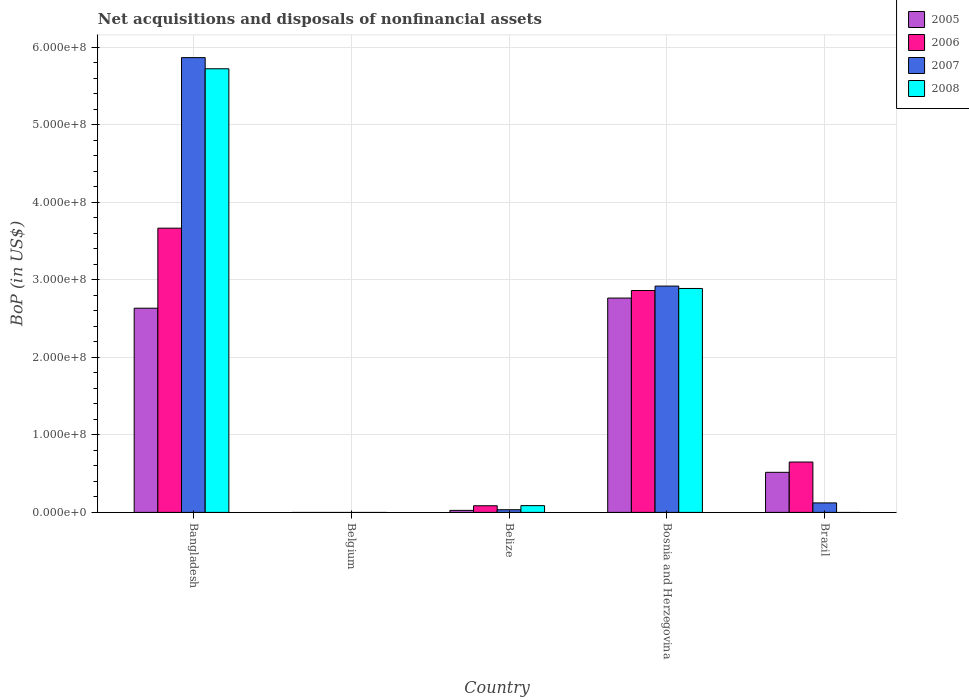How many different coloured bars are there?
Offer a very short reply. 4. Are the number of bars per tick equal to the number of legend labels?
Offer a terse response. No. Are the number of bars on each tick of the X-axis equal?
Provide a short and direct response. No. How many bars are there on the 3rd tick from the left?
Ensure brevity in your answer.  4. What is the label of the 5th group of bars from the left?
Your answer should be very brief. Brazil. In how many cases, is the number of bars for a given country not equal to the number of legend labels?
Offer a very short reply. 2. What is the Balance of Payments in 2008 in Bosnia and Herzegovina?
Offer a very short reply. 2.89e+08. Across all countries, what is the maximum Balance of Payments in 2006?
Your response must be concise. 3.67e+08. In which country was the Balance of Payments in 2005 maximum?
Provide a succinct answer. Bosnia and Herzegovina. What is the total Balance of Payments in 2007 in the graph?
Your answer should be very brief. 8.94e+08. What is the difference between the Balance of Payments in 2007 in Bangladesh and that in Brazil?
Your response must be concise. 5.74e+08. What is the difference between the Balance of Payments in 2008 in Belize and the Balance of Payments in 2005 in Bangladesh?
Your response must be concise. -2.55e+08. What is the average Balance of Payments in 2006 per country?
Make the answer very short. 1.45e+08. What is the difference between the Balance of Payments of/in 2007 and Balance of Payments of/in 2006 in Bosnia and Herzegovina?
Give a very brief answer. 5.67e+06. What is the ratio of the Balance of Payments in 2006 in Bosnia and Herzegovina to that in Brazil?
Give a very brief answer. 4.41. What is the difference between the highest and the second highest Balance of Payments in 2006?
Your response must be concise. -3.02e+08. What is the difference between the highest and the lowest Balance of Payments in 2007?
Offer a very short reply. 5.87e+08. Is the sum of the Balance of Payments in 2005 in Bangladesh and Belize greater than the maximum Balance of Payments in 2007 across all countries?
Make the answer very short. No. Is it the case that in every country, the sum of the Balance of Payments in 2005 and Balance of Payments in 2006 is greater than the sum of Balance of Payments in 2007 and Balance of Payments in 2008?
Provide a succinct answer. No. Is it the case that in every country, the sum of the Balance of Payments in 2005 and Balance of Payments in 2008 is greater than the Balance of Payments in 2006?
Your answer should be very brief. No. Are the values on the major ticks of Y-axis written in scientific E-notation?
Make the answer very short. Yes. Where does the legend appear in the graph?
Keep it short and to the point. Top right. How many legend labels are there?
Provide a short and direct response. 4. What is the title of the graph?
Your answer should be compact. Net acquisitions and disposals of nonfinancial assets. What is the label or title of the Y-axis?
Your answer should be compact. BoP (in US$). What is the BoP (in US$) in 2005 in Bangladesh?
Your response must be concise. 2.63e+08. What is the BoP (in US$) of 2006 in Bangladesh?
Ensure brevity in your answer.  3.67e+08. What is the BoP (in US$) in 2007 in Bangladesh?
Make the answer very short. 5.87e+08. What is the BoP (in US$) in 2008 in Bangladesh?
Your answer should be compact. 5.72e+08. What is the BoP (in US$) of 2005 in Belgium?
Provide a short and direct response. 0. What is the BoP (in US$) of 2008 in Belgium?
Offer a very short reply. 0. What is the BoP (in US$) in 2005 in Belize?
Provide a short and direct response. 2.59e+06. What is the BoP (in US$) in 2006 in Belize?
Give a very brief answer. 8.57e+06. What is the BoP (in US$) in 2007 in Belize?
Your answer should be very brief. 3.45e+06. What is the BoP (in US$) in 2008 in Belize?
Ensure brevity in your answer.  8.73e+06. What is the BoP (in US$) of 2005 in Bosnia and Herzegovina?
Provide a succinct answer. 2.76e+08. What is the BoP (in US$) in 2006 in Bosnia and Herzegovina?
Ensure brevity in your answer.  2.86e+08. What is the BoP (in US$) in 2007 in Bosnia and Herzegovina?
Provide a succinct answer. 2.92e+08. What is the BoP (in US$) of 2008 in Bosnia and Herzegovina?
Ensure brevity in your answer.  2.89e+08. What is the BoP (in US$) of 2005 in Brazil?
Offer a very short reply. 5.17e+07. What is the BoP (in US$) of 2006 in Brazil?
Your response must be concise. 6.50e+07. What is the BoP (in US$) of 2007 in Brazil?
Your answer should be very brief. 1.22e+07. Across all countries, what is the maximum BoP (in US$) in 2005?
Make the answer very short. 2.76e+08. Across all countries, what is the maximum BoP (in US$) of 2006?
Provide a succinct answer. 3.67e+08. Across all countries, what is the maximum BoP (in US$) in 2007?
Your answer should be very brief. 5.87e+08. Across all countries, what is the maximum BoP (in US$) in 2008?
Give a very brief answer. 5.72e+08. Across all countries, what is the minimum BoP (in US$) in 2005?
Your answer should be very brief. 0. Across all countries, what is the minimum BoP (in US$) of 2006?
Provide a succinct answer. 0. Across all countries, what is the minimum BoP (in US$) in 2007?
Make the answer very short. 0. What is the total BoP (in US$) in 2005 in the graph?
Offer a very short reply. 5.94e+08. What is the total BoP (in US$) of 2006 in the graph?
Keep it short and to the point. 7.26e+08. What is the total BoP (in US$) in 2007 in the graph?
Provide a short and direct response. 8.94e+08. What is the total BoP (in US$) in 2008 in the graph?
Your answer should be compact. 8.70e+08. What is the difference between the BoP (in US$) of 2005 in Bangladesh and that in Belize?
Keep it short and to the point. 2.61e+08. What is the difference between the BoP (in US$) in 2006 in Bangladesh and that in Belize?
Make the answer very short. 3.58e+08. What is the difference between the BoP (in US$) in 2007 in Bangladesh and that in Belize?
Provide a short and direct response. 5.83e+08. What is the difference between the BoP (in US$) of 2008 in Bangladesh and that in Belize?
Offer a very short reply. 5.63e+08. What is the difference between the BoP (in US$) of 2005 in Bangladesh and that in Bosnia and Herzegovina?
Give a very brief answer. -1.31e+07. What is the difference between the BoP (in US$) of 2006 in Bangladesh and that in Bosnia and Herzegovina?
Your answer should be compact. 8.04e+07. What is the difference between the BoP (in US$) in 2007 in Bangladesh and that in Bosnia and Herzegovina?
Your answer should be compact. 2.95e+08. What is the difference between the BoP (in US$) of 2008 in Bangladesh and that in Bosnia and Herzegovina?
Provide a short and direct response. 2.83e+08. What is the difference between the BoP (in US$) in 2005 in Bangladesh and that in Brazil?
Offer a very short reply. 2.12e+08. What is the difference between the BoP (in US$) in 2006 in Bangladesh and that in Brazil?
Ensure brevity in your answer.  3.02e+08. What is the difference between the BoP (in US$) in 2007 in Bangladesh and that in Brazil?
Make the answer very short. 5.74e+08. What is the difference between the BoP (in US$) of 2005 in Belize and that in Bosnia and Herzegovina?
Make the answer very short. -2.74e+08. What is the difference between the BoP (in US$) in 2006 in Belize and that in Bosnia and Herzegovina?
Keep it short and to the point. -2.78e+08. What is the difference between the BoP (in US$) in 2007 in Belize and that in Bosnia and Herzegovina?
Ensure brevity in your answer.  -2.88e+08. What is the difference between the BoP (in US$) of 2008 in Belize and that in Bosnia and Herzegovina?
Your answer should be compact. -2.80e+08. What is the difference between the BoP (in US$) of 2005 in Belize and that in Brazil?
Keep it short and to the point. -4.91e+07. What is the difference between the BoP (in US$) in 2006 in Belize and that in Brazil?
Your answer should be compact. -5.64e+07. What is the difference between the BoP (in US$) of 2007 in Belize and that in Brazil?
Provide a succinct answer. -8.78e+06. What is the difference between the BoP (in US$) of 2005 in Bosnia and Herzegovina and that in Brazil?
Provide a succinct answer. 2.25e+08. What is the difference between the BoP (in US$) of 2006 in Bosnia and Herzegovina and that in Brazil?
Your answer should be very brief. 2.21e+08. What is the difference between the BoP (in US$) of 2007 in Bosnia and Herzegovina and that in Brazil?
Give a very brief answer. 2.80e+08. What is the difference between the BoP (in US$) in 2005 in Bangladesh and the BoP (in US$) in 2006 in Belize?
Make the answer very short. 2.55e+08. What is the difference between the BoP (in US$) in 2005 in Bangladesh and the BoP (in US$) in 2007 in Belize?
Make the answer very short. 2.60e+08. What is the difference between the BoP (in US$) in 2005 in Bangladesh and the BoP (in US$) in 2008 in Belize?
Ensure brevity in your answer.  2.55e+08. What is the difference between the BoP (in US$) in 2006 in Bangladesh and the BoP (in US$) in 2007 in Belize?
Keep it short and to the point. 3.63e+08. What is the difference between the BoP (in US$) in 2006 in Bangladesh and the BoP (in US$) in 2008 in Belize?
Give a very brief answer. 3.58e+08. What is the difference between the BoP (in US$) of 2007 in Bangladesh and the BoP (in US$) of 2008 in Belize?
Provide a short and direct response. 5.78e+08. What is the difference between the BoP (in US$) of 2005 in Bangladesh and the BoP (in US$) of 2006 in Bosnia and Herzegovina?
Give a very brief answer. -2.29e+07. What is the difference between the BoP (in US$) in 2005 in Bangladesh and the BoP (in US$) in 2007 in Bosnia and Herzegovina?
Your answer should be very brief. -2.85e+07. What is the difference between the BoP (in US$) in 2005 in Bangladesh and the BoP (in US$) in 2008 in Bosnia and Herzegovina?
Your response must be concise. -2.55e+07. What is the difference between the BoP (in US$) of 2006 in Bangladesh and the BoP (in US$) of 2007 in Bosnia and Herzegovina?
Your answer should be compact. 7.47e+07. What is the difference between the BoP (in US$) of 2006 in Bangladesh and the BoP (in US$) of 2008 in Bosnia and Herzegovina?
Give a very brief answer. 7.78e+07. What is the difference between the BoP (in US$) in 2007 in Bangladesh and the BoP (in US$) in 2008 in Bosnia and Herzegovina?
Offer a terse response. 2.98e+08. What is the difference between the BoP (in US$) in 2005 in Bangladesh and the BoP (in US$) in 2006 in Brazil?
Provide a short and direct response. 1.98e+08. What is the difference between the BoP (in US$) of 2005 in Bangladesh and the BoP (in US$) of 2007 in Brazil?
Make the answer very short. 2.51e+08. What is the difference between the BoP (in US$) of 2006 in Bangladesh and the BoP (in US$) of 2007 in Brazil?
Give a very brief answer. 3.54e+08. What is the difference between the BoP (in US$) in 2005 in Belize and the BoP (in US$) in 2006 in Bosnia and Herzegovina?
Keep it short and to the point. -2.84e+08. What is the difference between the BoP (in US$) of 2005 in Belize and the BoP (in US$) of 2007 in Bosnia and Herzegovina?
Ensure brevity in your answer.  -2.89e+08. What is the difference between the BoP (in US$) in 2005 in Belize and the BoP (in US$) in 2008 in Bosnia and Herzegovina?
Keep it short and to the point. -2.86e+08. What is the difference between the BoP (in US$) in 2006 in Belize and the BoP (in US$) in 2007 in Bosnia and Herzegovina?
Provide a succinct answer. -2.83e+08. What is the difference between the BoP (in US$) in 2006 in Belize and the BoP (in US$) in 2008 in Bosnia and Herzegovina?
Offer a terse response. -2.80e+08. What is the difference between the BoP (in US$) of 2007 in Belize and the BoP (in US$) of 2008 in Bosnia and Herzegovina?
Your answer should be compact. -2.85e+08. What is the difference between the BoP (in US$) in 2005 in Belize and the BoP (in US$) in 2006 in Brazil?
Provide a short and direct response. -6.24e+07. What is the difference between the BoP (in US$) of 2005 in Belize and the BoP (in US$) of 2007 in Brazil?
Offer a terse response. -9.64e+06. What is the difference between the BoP (in US$) of 2006 in Belize and the BoP (in US$) of 2007 in Brazil?
Your answer should be very brief. -3.66e+06. What is the difference between the BoP (in US$) of 2005 in Bosnia and Herzegovina and the BoP (in US$) of 2006 in Brazil?
Make the answer very short. 2.11e+08. What is the difference between the BoP (in US$) in 2005 in Bosnia and Herzegovina and the BoP (in US$) in 2007 in Brazil?
Offer a very short reply. 2.64e+08. What is the difference between the BoP (in US$) of 2006 in Bosnia and Herzegovina and the BoP (in US$) of 2007 in Brazil?
Your answer should be compact. 2.74e+08. What is the average BoP (in US$) in 2005 per country?
Provide a succinct answer. 1.19e+08. What is the average BoP (in US$) in 2006 per country?
Ensure brevity in your answer.  1.45e+08. What is the average BoP (in US$) in 2007 per country?
Your answer should be very brief. 1.79e+08. What is the average BoP (in US$) in 2008 per country?
Provide a short and direct response. 1.74e+08. What is the difference between the BoP (in US$) in 2005 and BoP (in US$) in 2006 in Bangladesh?
Give a very brief answer. -1.03e+08. What is the difference between the BoP (in US$) of 2005 and BoP (in US$) of 2007 in Bangladesh?
Make the answer very short. -3.23e+08. What is the difference between the BoP (in US$) of 2005 and BoP (in US$) of 2008 in Bangladesh?
Make the answer very short. -3.09e+08. What is the difference between the BoP (in US$) in 2006 and BoP (in US$) in 2007 in Bangladesh?
Keep it short and to the point. -2.20e+08. What is the difference between the BoP (in US$) of 2006 and BoP (in US$) of 2008 in Bangladesh?
Your answer should be very brief. -2.06e+08. What is the difference between the BoP (in US$) of 2007 and BoP (in US$) of 2008 in Bangladesh?
Give a very brief answer. 1.44e+07. What is the difference between the BoP (in US$) in 2005 and BoP (in US$) in 2006 in Belize?
Provide a succinct answer. -5.98e+06. What is the difference between the BoP (in US$) of 2005 and BoP (in US$) of 2007 in Belize?
Your answer should be very brief. -8.56e+05. What is the difference between the BoP (in US$) in 2005 and BoP (in US$) in 2008 in Belize?
Ensure brevity in your answer.  -6.14e+06. What is the difference between the BoP (in US$) in 2006 and BoP (in US$) in 2007 in Belize?
Offer a very short reply. 5.12e+06. What is the difference between the BoP (in US$) in 2006 and BoP (in US$) in 2008 in Belize?
Provide a short and direct response. -1.61e+05. What is the difference between the BoP (in US$) in 2007 and BoP (in US$) in 2008 in Belize?
Offer a very short reply. -5.28e+06. What is the difference between the BoP (in US$) of 2005 and BoP (in US$) of 2006 in Bosnia and Herzegovina?
Offer a terse response. -9.77e+06. What is the difference between the BoP (in US$) of 2005 and BoP (in US$) of 2007 in Bosnia and Herzegovina?
Make the answer very short. -1.54e+07. What is the difference between the BoP (in US$) in 2005 and BoP (in US$) in 2008 in Bosnia and Herzegovina?
Your response must be concise. -1.24e+07. What is the difference between the BoP (in US$) of 2006 and BoP (in US$) of 2007 in Bosnia and Herzegovina?
Make the answer very short. -5.67e+06. What is the difference between the BoP (in US$) in 2006 and BoP (in US$) in 2008 in Bosnia and Herzegovina?
Ensure brevity in your answer.  -2.60e+06. What is the difference between the BoP (in US$) in 2007 and BoP (in US$) in 2008 in Bosnia and Herzegovina?
Your response must be concise. 3.07e+06. What is the difference between the BoP (in US$) in 2005 and BoP (in US$) in 2006 in Brazil?
Your answer should be compact. -1.33e+07. What is the difference between the BoP (in US$) of 2005 and BoP (in US$) of 2007 in Brazil?
Your response must be concise. 3.95e+07. What is the difference between the BoP (in US$) in 2006 and BoP (in US$) in 2007 in Brazil?
Give a very brief answer. 5.27e+07. What is the ratio of the BoP (in US$) in 2005 in Bangladesh to that in Belize?
Ensure brevity in your answer.  101.69. What is the ratio of the BoP (in US$) of 2006 in Bangladesh to that in Belize?
Your response must be concise. 42.8. What is the ratio of the BoP (in US$) in 2007 in Bangladesh to that in Belize?
Your answer should be compact. 170.21. What is the ratio of the BoP (in US$) in 2008 in Bangladesh to that in Belize?
Your answer should be very brief. 65.57. What is the ratio of the BoP (in US$) of 2005 in Bangladesh to that in Bosnia and Herzegovina?
Keep it short and to the point. 0.95. What is the ratio of the BoP (in US$) of 2006 in Bangladesh to that in Bosnia and Herzegovina?
Your answer should be very brief. 1.28. What is the ratio of the BoP (in US$) in 2007 in Bangladesh to that in Bosnia and Herzegovina?
Give a very brief answer. 2.01. What is the ratio of the BoP (in US$) of 2008 in Bangladesh to that in Bosnia and Herzegovina?
Your answer should be very brief. 1.98. What is the ratio of the BoP (in US$) of 2005 in Bangladesh to that in Brazil?
Make the answer very short. 5.09. What is the ratio of the BoP (in US$) of 2006 in Bangladesh to that in Brazil?
Your answer should be compact. 5.64. What is the ratio of the BoP (in US$) of 2007 in Bangladesh to that in Brazil?
Keep it short and to the point. 47.96. What is the ratio of the BoP (in US$) in 2005 in Belize to that in Bosnia and Herzegovina?
Give a very brief answer. 0.01. What is the ratio of the BoP (in US$) of 2006 in Belize to that in Bosnia and Herzegovina?
Your response must be concise. 0.03. What is the ratio of the BoP (in US$) in 2007 in Belize to that in Bosnia and Herzegovina?
Give a very brief answer. 0.01. What is the ratio of the BoP (in US$) in 2008 in Belize to that in Bosnia and Herzegovina?
Your response must be concise. 0.03. What is the ratio of the BoP (in US$) of 2005 in Belize to that in Brazil?
Your answer should be compact. 0.05. What is the ratio of the BoP (in US$) of 2006 in Belize to that in Brazil?
Provide a short and direct response. 0.13. What is the ratio of the BoP (in US$) in 2007 in Belize to that in Brazil?
Your answer should be very brief. 0.28. What is the ratio of the BoP (in US$) of 2005 in Bosnia and Herzegovina to that in Brazil?
Your answer should be very brief. 5.35. What is the ratio of the BoP (in US$) of 2006 in Bosnia and Herzegovina to that in Brazil?
Your response must be concise. 4.41. What is the ratio of the BoP (in US$) of 2007 in Bosnia and Herzegovina to that in Brazil?
Ensure brevity in your answer.  23.87. What is the difference between the highest and the second highest BoP (in US$) of 2005?
Offer a very short reply. 1.31e+07. What is the difference between the highest and the second highest BoP (in US$) of 2006?
Keep it short and to the point. 8.04e+07. What is the difference between the highest and the second highest BoP (in US$) in 2007?
Provide a short and direct response. 2.95e+08. What is the difference between the highest and the second highest BoP (in US$) in 2008?
Give a very brief answer. 2.83e+08. What is the difference between the highest and the lowest BoP (in US$) in 2005?
Keep it short and to the point. 2.76e+08. What is the difference between the highest and the lowest BoP (in US$) in 2006?
Offer a very short reply. 3.67e+08. What is the difference between the highest and the lowest BoP (in US$) in 2007?
Make the answer very short. 5.87e+08. What is the difference between the highest and the lowest BoP (in US$) in 2008?
Your answer should be very brief. 5.72e+08. 